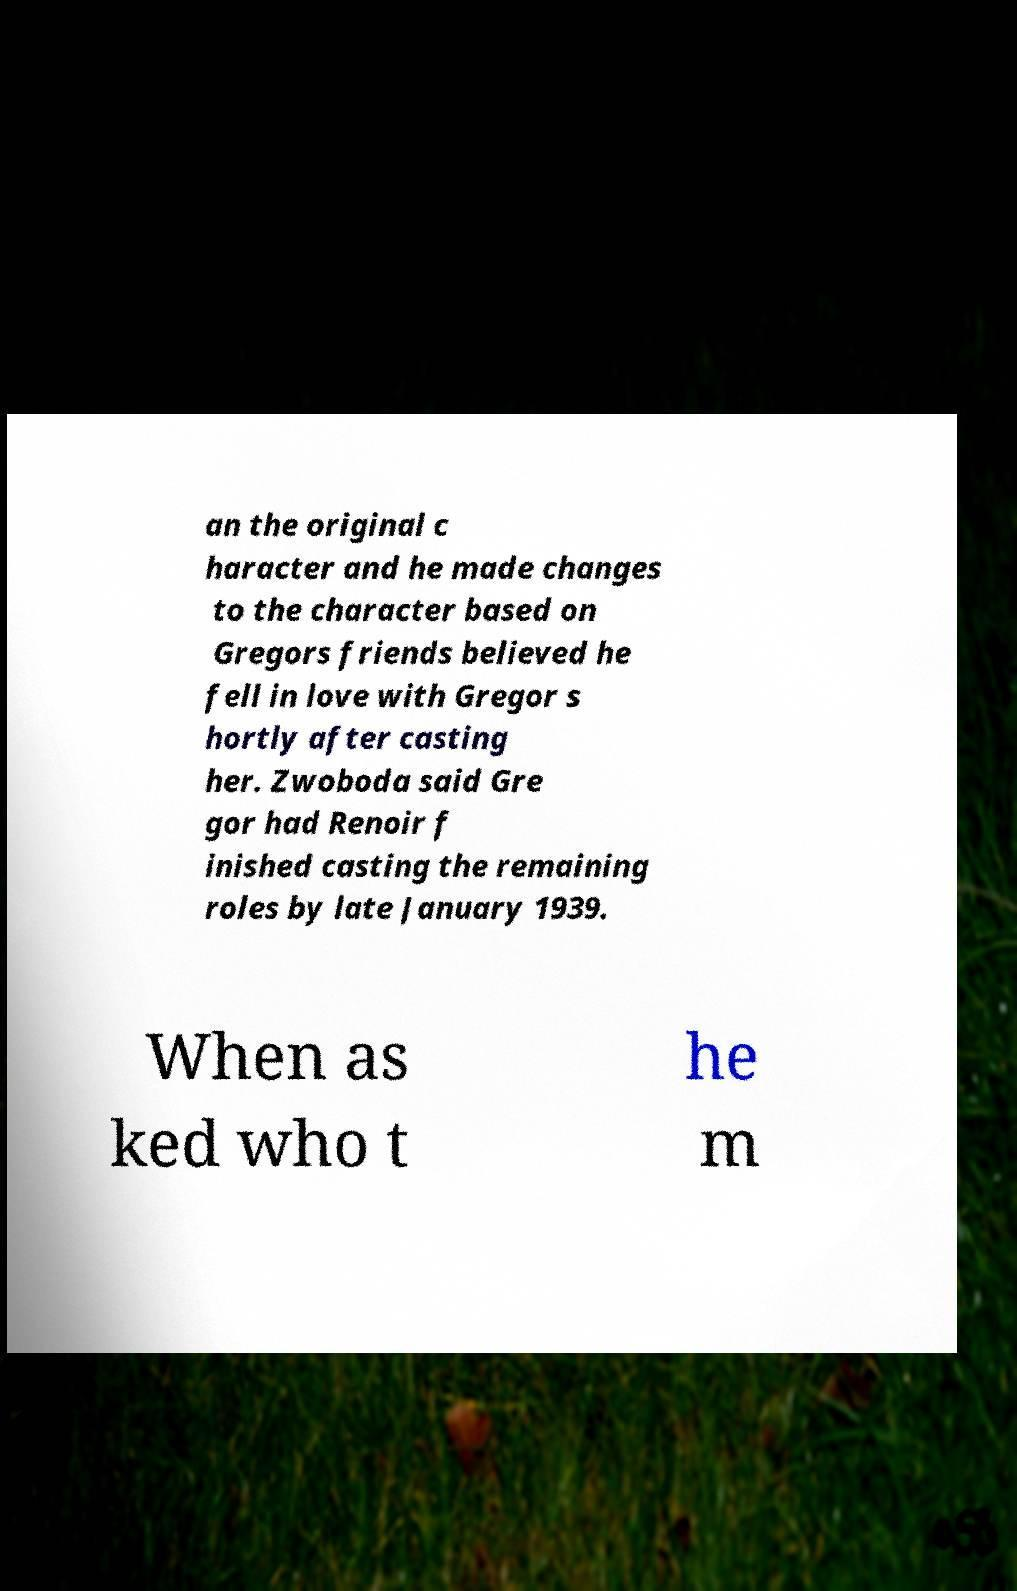I need the written content from this picture converted into text. Can you do that? an the original c haracter and he made changes to the character based on Gregors friends believed he fell in love with Gregor s hortly after casting her. Zwoboda said Gre gor had Renoir f inished casting the remaining roles by late January 1939. When as ked who t he m 